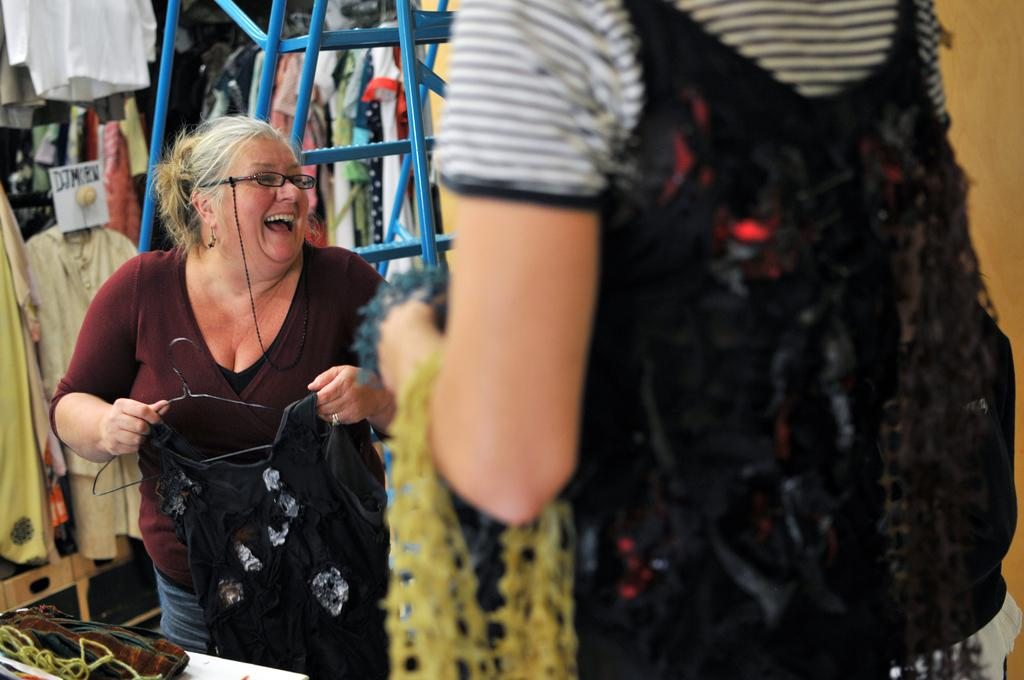Who is present in the image? There is a woman in the image. What is the woman holding in the image? The woman is holding clothes in the image. What can be seen in the background of the image? There is a ladder, clothes, and a wall visible in the background of the image. What type of cow can be seen grazing in the field in the image? There is no field or cow present in the image. What subject is being taught in the school visible in the image? There is no school present in the image. 